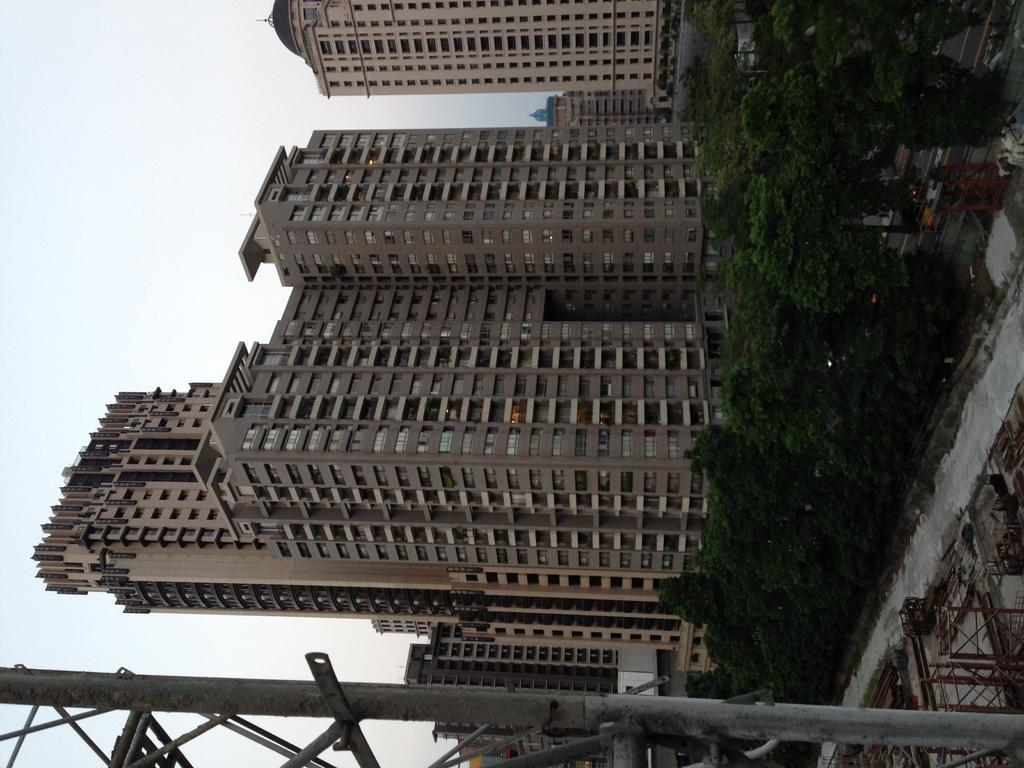What type of natural elements can be seen in the image? There are trees in the image. What type of man-made structures are present in the image? There are buildings in the image. What is the tall, vertical object in the image? There is a pole in the image. What type of transportation infrastructure is visible in the image? There are roads in the image. What objects can be found on the ground in the image? There are objects on the ground in the image. How would you describe the weather in the image? The sky is cloudy in the image. How many fifths are present in the image? There is no mention of a "fifth" in the image, so it cannot be determined how many there are. What type of sack can be seen hanging from the pole in the image? There is no sack hanging from the pole in the image. 